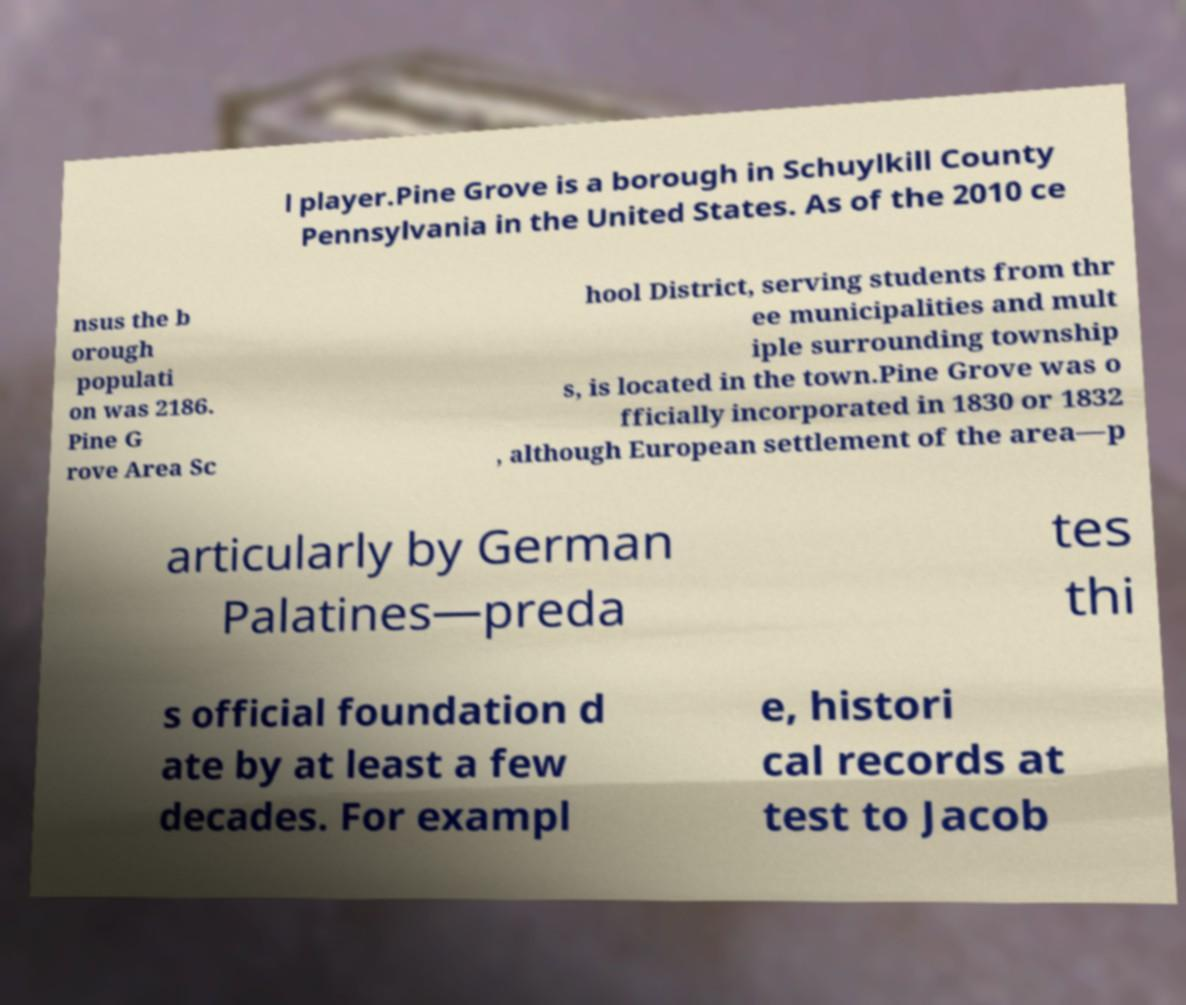I need the written content from this picture converted into text. Can you do that? l player.Pine Grove is a borough in Schuylkill County Pennsylvania in the United States. As of the 2010 ce nsus the b orough populati on was 2186. Pine G rove Area Sc hool District, serving students from thr ee municipalities and mult iple surrounding township s, is located in the town.Pine Grove was o fficially incorporated in 1830 or 1832 , although European settlement of the area—p articularly by German Palatines—preda tes thi s official foundation d ate by at least a few decades. For exampl e, histori cal records at test to Jacob 